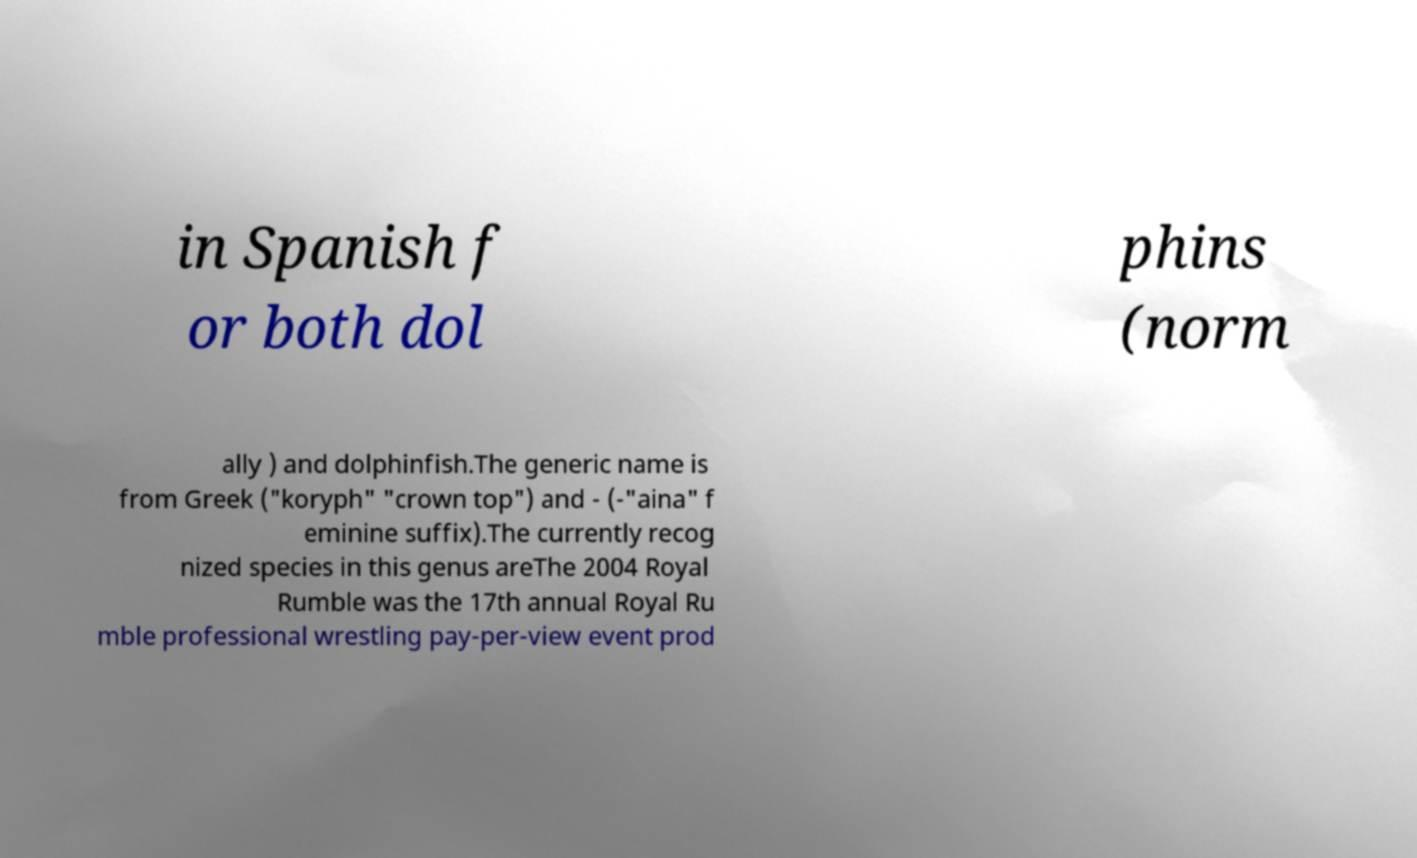Could you assist in decoding the text presented in this image and type it out clearly? in Spanish f or both dol phins (norm ally ) and dolphinfish.The generic name is from Greek ("koryph" "crown top") and - (-"aina" f eminine suffix).The currently recog nized species in this genus areThe 2004 Royal Rumble was the 17th annual Royal Ru mble professional wrestling pay-per-view event prod 